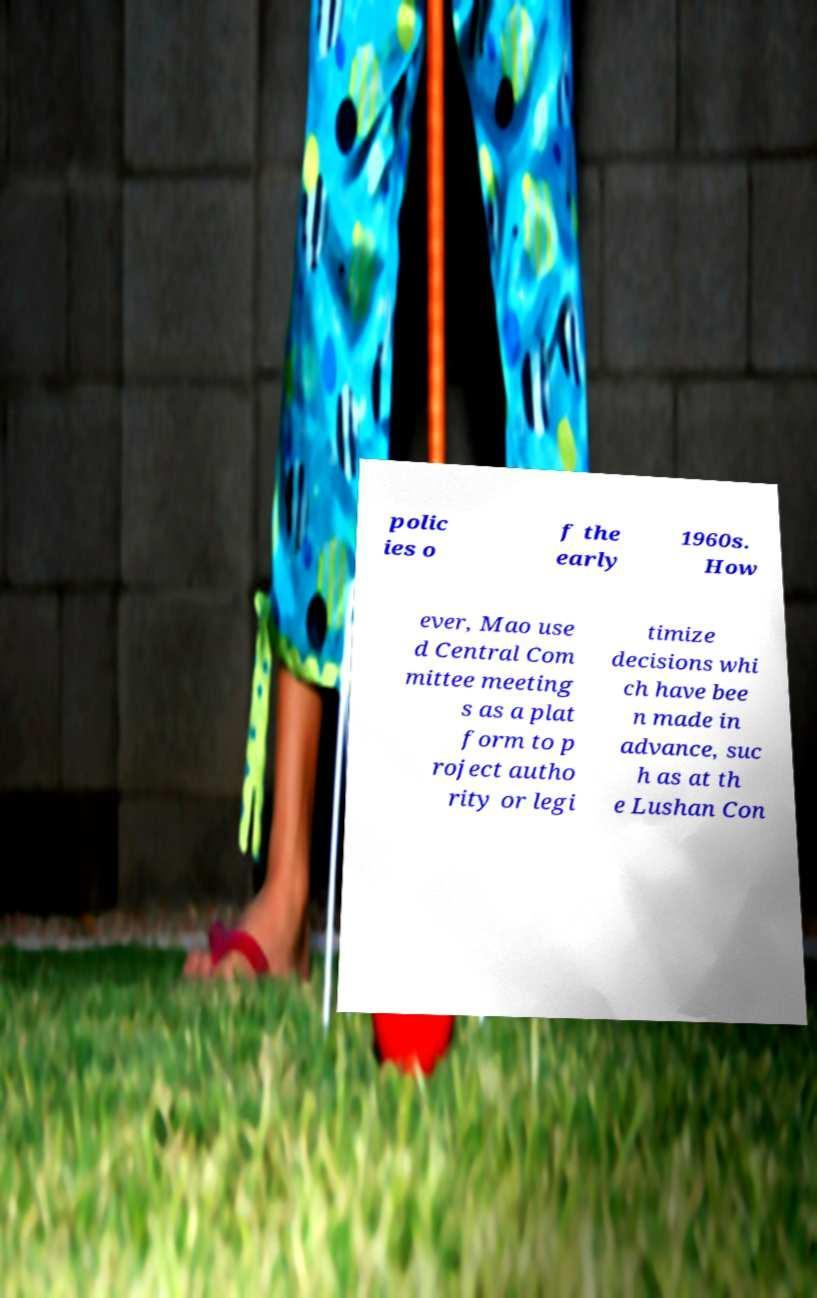For documentation purposes, I need the text within this image transcribed. Could you provide that? polic ies o f the early 1960s. How ever, Mao use d Central Com mittee meeting s as a plat form to p roject autho rity or legi timize decisions whi ch have bee n made in advance, suc h as at th e Lushan Con 